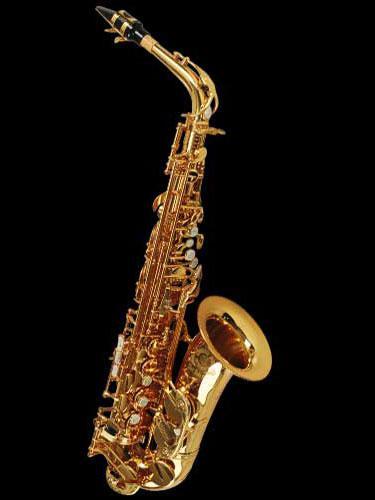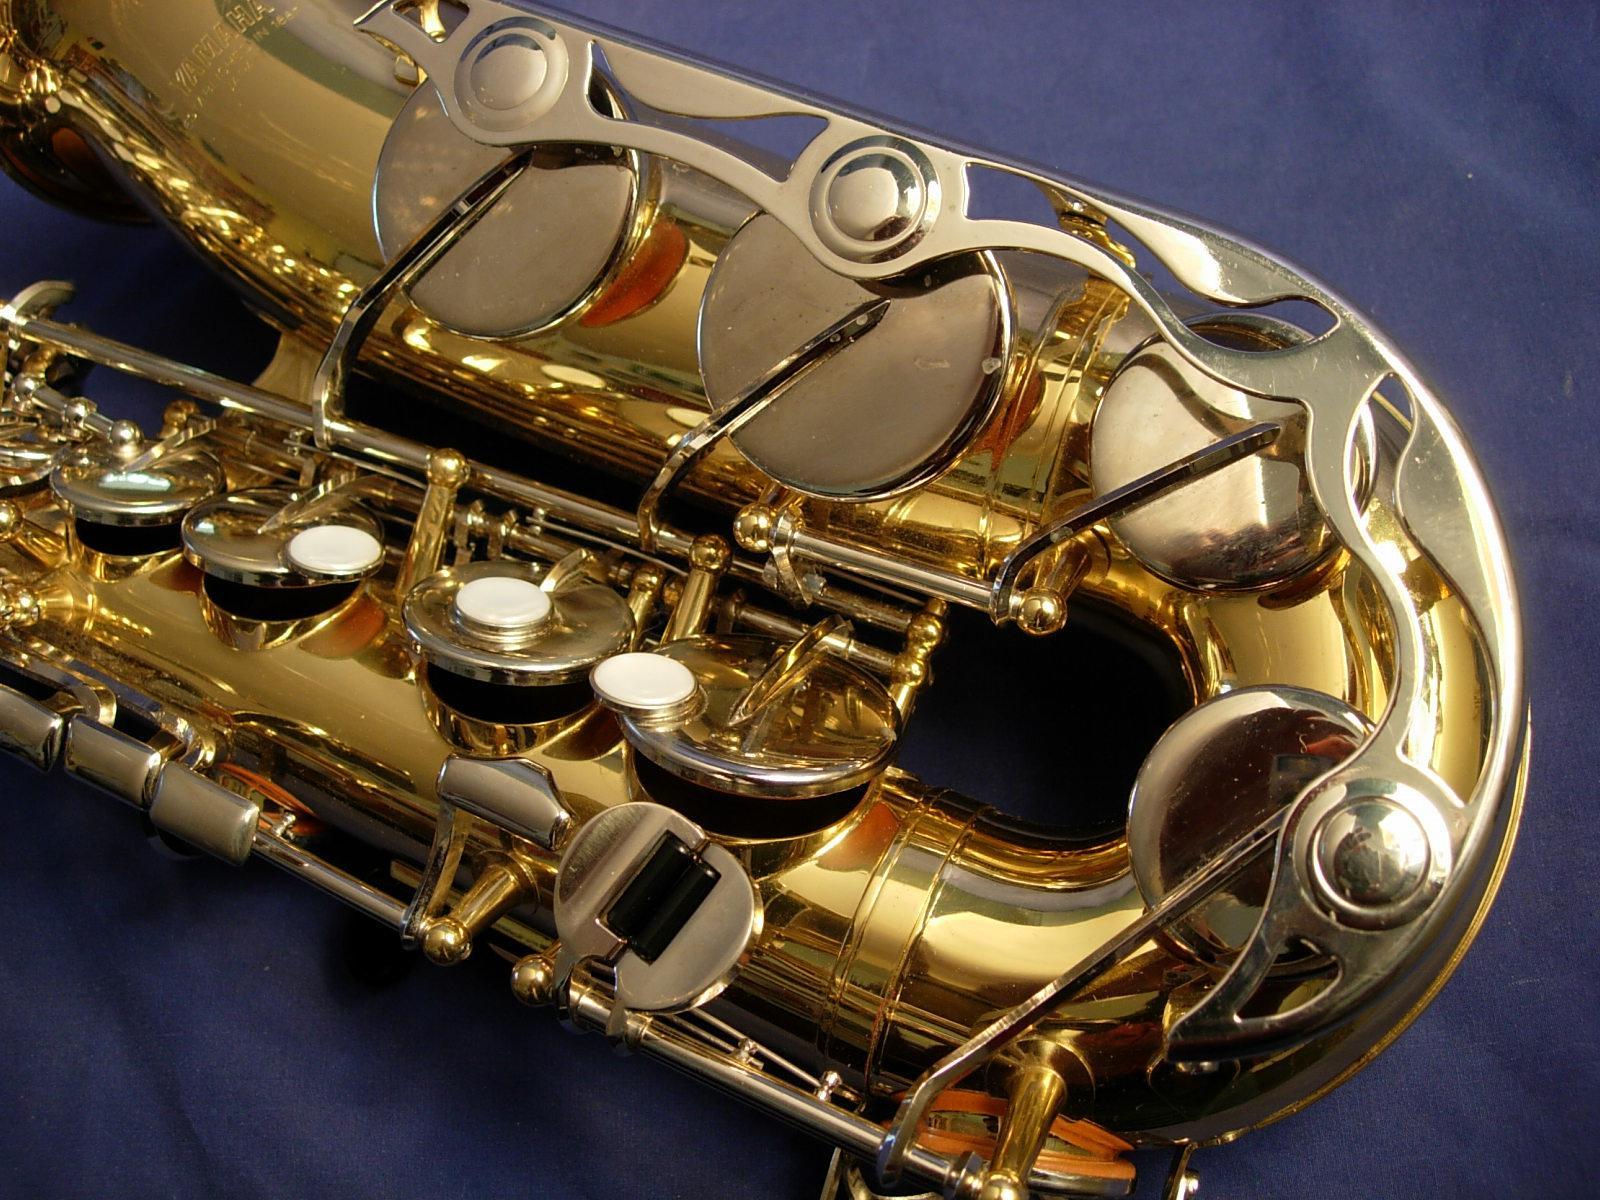The first image is the image on the left, the second image is the image on the right. For the images displayed, is the sentence "At least two saxophones face left." factually correct? Answer yes or no. No. 